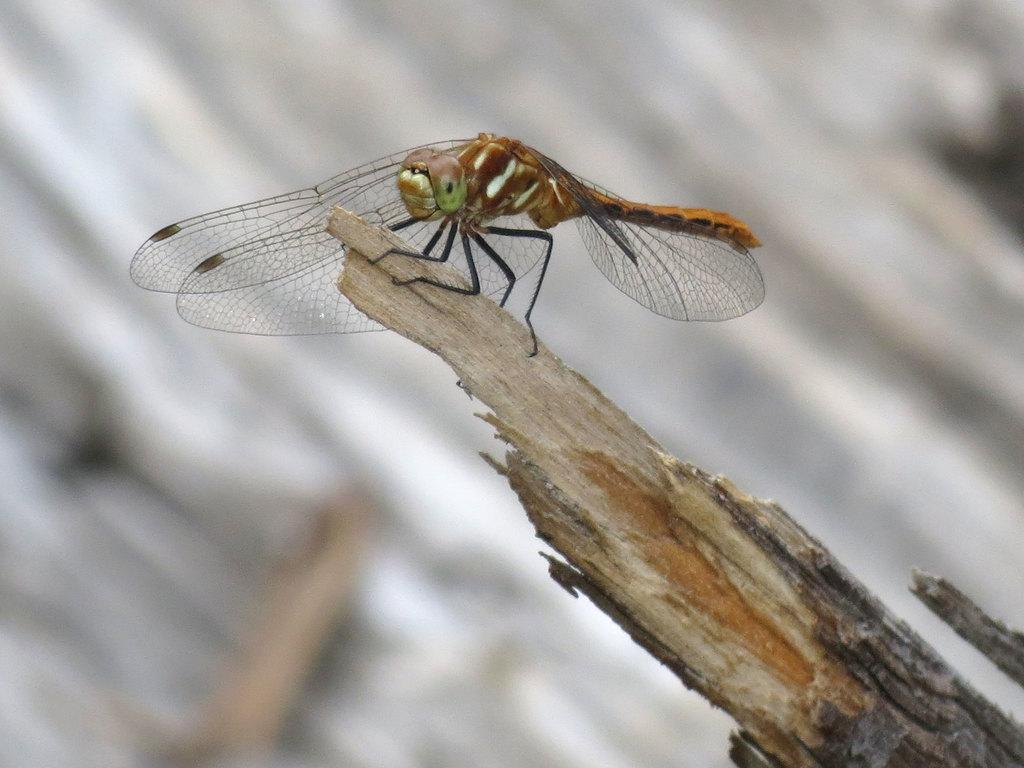What type of creature is in the image? There is an insect in the image. What specific features does the insect have? The insect has wings and legs. Where is the insect located in the image? The insect is standing near the edge of a tree branch. How would you describe the background of the image? The background of the image is blurred. How many legs does the person have in the image? There is no person present in the image, only an insect. What type of bun is the insect holding in the image? There is no bun present in the image; the insect has wings and legs, but no bun. 